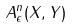<formula> <loc_0><loc_0><loc_500><loc_500>A _ { \epsilon } ^ { n } ( X , Y )</formula> 